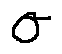<formula> <loc_0><loc_0><loc_500><loc_500>\sigma</formula> 